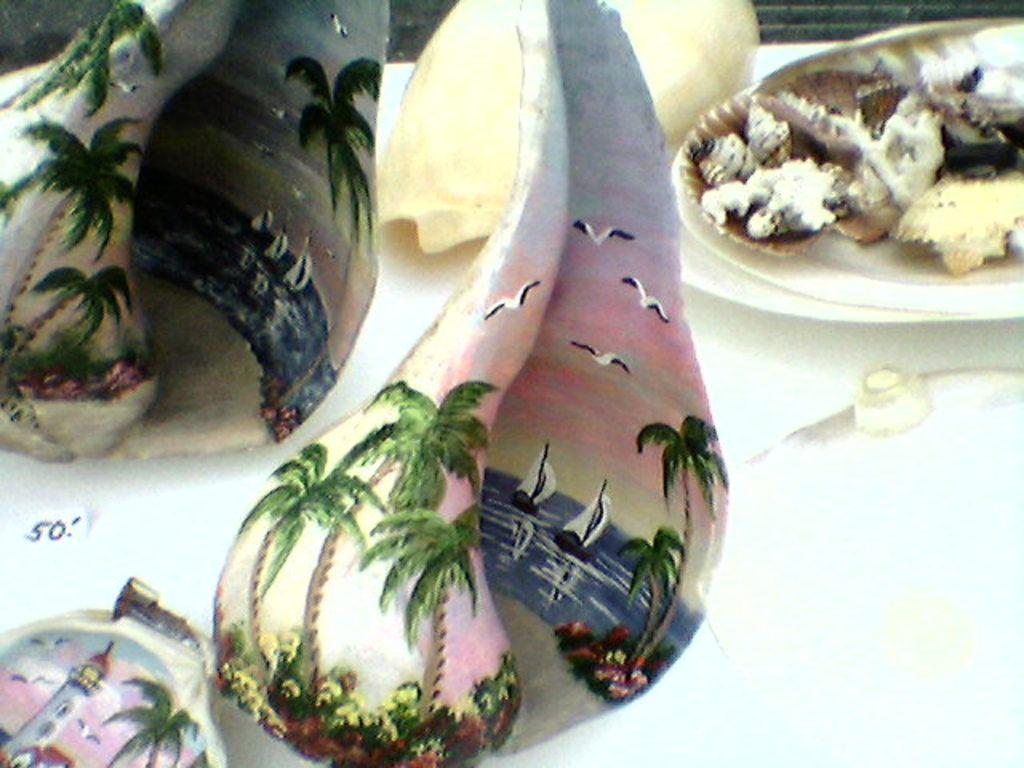What is depicted on the objects in the image? There are paintings on shells in the image. What is the color of the surface on which the shells are placed? The shells are on a white color surface. How does the beggar interact with the shells in the image? There is no beggar present in the image; it only features shells with paintings on them. What type of advice can be given using the wrench in the image? There is no wrench present in the image, so no advice can be given using it. 